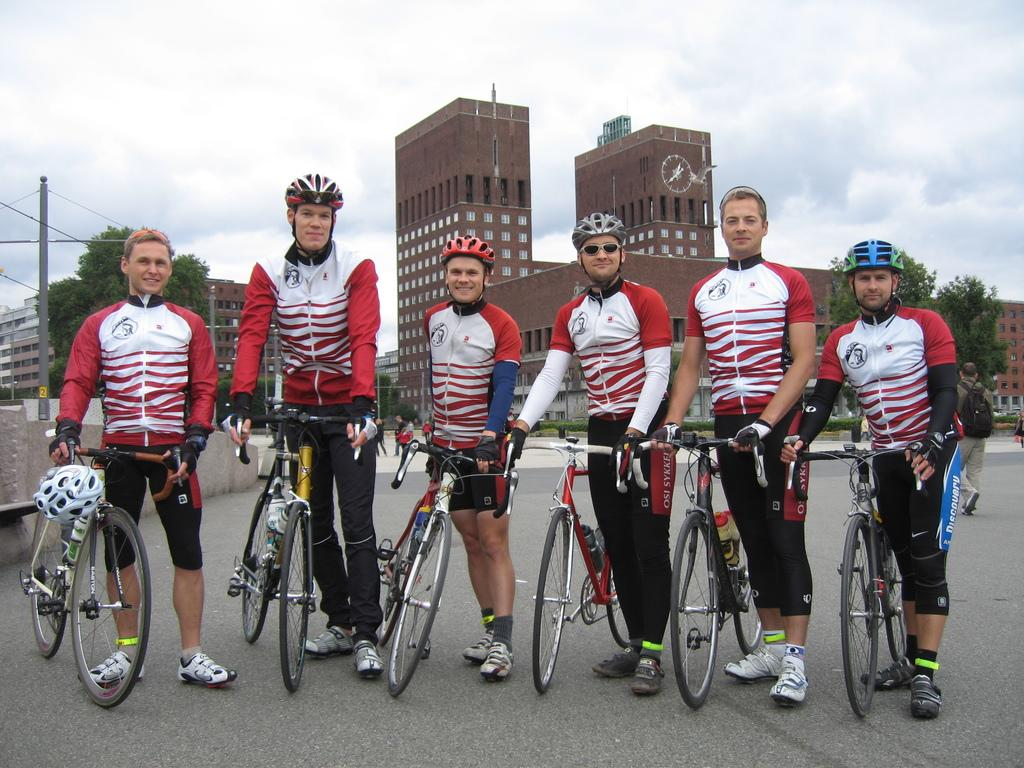What can be seen in the image? There is a group of men in the image. What are the men wearing? The men are wearing helmets and goggles. What are the men holding? The men are holding bicycles. How are the bicycles being held? The bicycles are in their hands. Where is the scene taking place? The scene takes place on a road. What can be seen in the background of the image? There is a tree, a building with windows, and the sky visible in the background. What is the condition of the sky? Clouds are present in the sky. How many pages of text can be seen in the image? There are no pages of text present in the image. What type of chickens can be seen in the image? There are no chickens present in the image. 